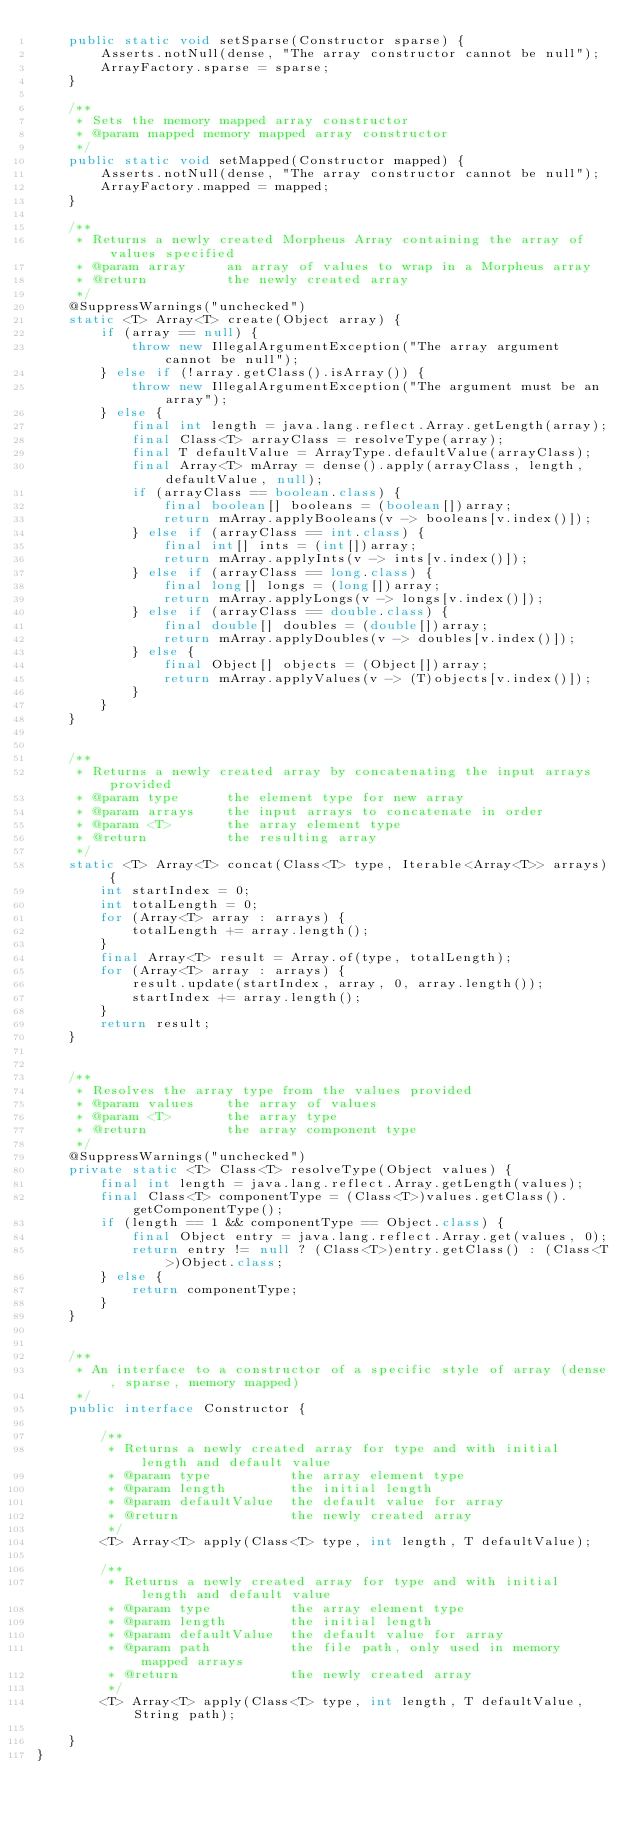Convert code to text. <code><loc_0><loc_0><loc_500><loc_500><_Java_>    public static void setSparse(Constructor sparse) {
        Asserts.notNull(dense, "The array constructor cannot be null");
        ArrayFactory.sparse = sparse;
    }

    /**
     * Sets the memory mapped array constructor
     * @param mapped memory mapped array constructor
     */
    public static void setMapped(Constructor mapped) {
        Asserts.notNull(dense, "The array constructor cannot be null");
        ArrayFactory.mapped = mapped;
    }

    /**
     * Returns a newly created Morpheus Array containing the array of values specified
     * @param array     an array of values to wrap in a Morpheus array
     * @return          the newly created array
     */
    @SuppressWarnings("unchecked")
    static <T> Array<T> create(Object array) {
        if (array == null) {
            throw new IllegalArgumentException("The array argument cannot be null");
        } else if (!array.getClass().isArray()) {
            throw new IllegalArgumentException("The argument must be an array");
        } else {
            final int length = java.lang.reflect.Array.getLength(array);
            final Class<T> arrayClass = resolveType(array);
            final T defaultValue = ArrayType.defaultValue(arrayClass);
            final Array<T> mArray = dense().apply(arrayClass, length, defaultValue, null);
            if (arrayClass == boolean.class) {
                final boolean[] booleans = (boolean[])array;
                return mArray.applyBooleans(v -> booleans[v.index()]);
            } else if (arrayClass == int.class) {
                final int[] ints = (int[])array;
                return mArray.applyInts(v -> ints[v.index()]);
            } else if (arrayClass == long.class) {
                final long[] longs = (long[])array;
                return mArray.applyLongs(v -> longs[v.index()]);
            } else if (arrayClass == double.class) {
                final double[] doubles = (double[])array;
                return mArray.applyDoubles(v -> doubles[v.index()]);
            } else {
                final Object[] objects = (Object[])array;
                return mArray.applyValues(v -> (T)objects[v.index()]);
            }
        }
    }


    /**
     * Returns a newly created array by concatenating the input arrays provided
     * @param type      the element type for new array
     * @param arrays    the input arrays to concatenate in order
     * @param <T>       the array element type
     * @return          the resulting array
     */
    static <T> Array<T> concat(Class<T> type, Iterable<Array<T>> arrays) {
        int startIndex = 0;
        int totalLength = 0;
        for (Array<T> array : arrays) {
            totalLength += array.length();
        }
        final Array<T> result = Array.of(type, totalLength);
        for (Array<T> array : arrays) {
            result.update(startIndex, array, 0, array.length());
            startIndex += array.length();
        }
        return result;
    }


    /**
     * Resolves the array type from the values provided
     * @param values    the array of values
     * @param <T>       the array type
     * @return          the array component type
     */
    @SuppressWarnings("unchecked")
    private static <T> Class<T> resolveType(Object values) {
        final int length = java.lang.reflect.Array.getLength(values);
        final Class<T> componentType = (Class<T>)values.getClass().getComponentType();
        if (length == 1 && componentType == Object.class) {
            final Object entry = java.lang.reflect.Array.get(values, 0);
            return entry != null ? (Class<T>)entry.getClass() : (Class<T>)Object.class;
        } else {
            return componentType;
        }
    }


    /**
     * An interface to a constructor of a specific style of array (dense, sparse, memory mapped)
     */
    public interface Constructor {

        /**
         * Returns a newly created array for type and with initial length and default value
         * @param type          the array element type
         * @param length        the initial length
         * @param defaultValue  the default value for array
         * @return              the newly created array
         */
        <T> Array<T> apply(Class<T> type, int length, T defaultValue);

        /**
         * Returns a newly created array for type and with initial length and default value
         * @param type          the array element type
         * @param length        the initial length
         * @param defaultValue  the default value for array
         * @param path          the file path, only used in memory mapped arrays
         * @return              the newly created array
         */
        <T> Array<T> apply(Class<T> type, int length, T defaultValue, String path);

    }
}
</code> 